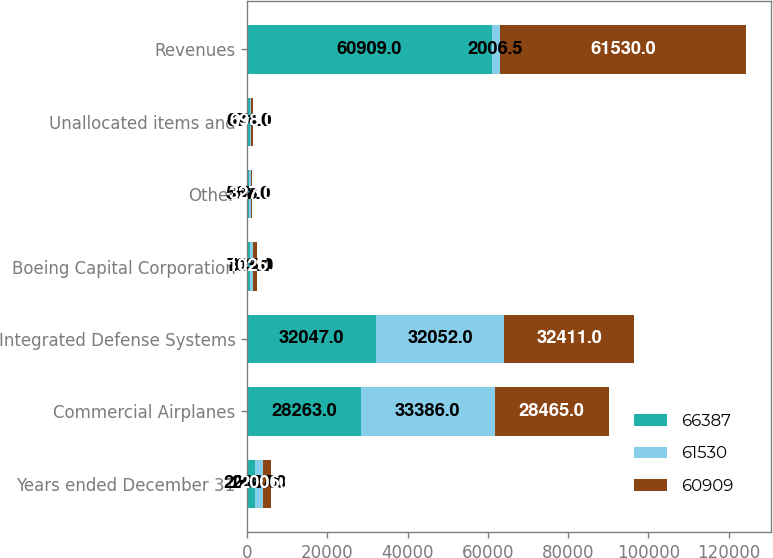Convert chart. <chart><loc_0><loc_0><loc_500><loc_500><stacked_bar_chart><ecel><fcel>Years ended December 31<fcel>Commercial Airplanes<fcel>Integrated Defense Systems<fcel>Boeing Capital Corporation<fcel>Other<fcel>Unallocated items and<fcel>Revenues<nl><fcel>66387<fcel>2008<fcel>28263<fcel>32047<fcel>703<fcel>567<fcel>671<fcel>60909<nl><fcel>61530<fcel>2007<fcel>33386<fcel>32052<fcel>815<fcel>308<fcel>174<fcel>2006.5<nl><fcel>60909<fcel>2006<fcel>28465<fcel>32411<fcel>1025<fcel>327<fcel>698<fcel>61530<nl></chart> 